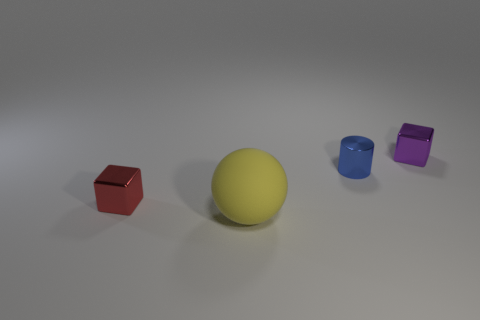Add 1 tiny red metallic blocks. How many objects exist? 5 Subtract all balls. How many objects are left? 3 Add 1 small blue objects. How many small blue objects exist? 2 Subtract 0 brown cylinders. How many objects are left? 4 Subtract all cyan spheres. Subtract all blue blocks. How many spheres are left? 1 Subtract all blue metallic cylinders. Subtract all metal things. How many objects are left? 0 Add 3 big yellow matte spheres. How many big yellow matte spheres are left? 4 